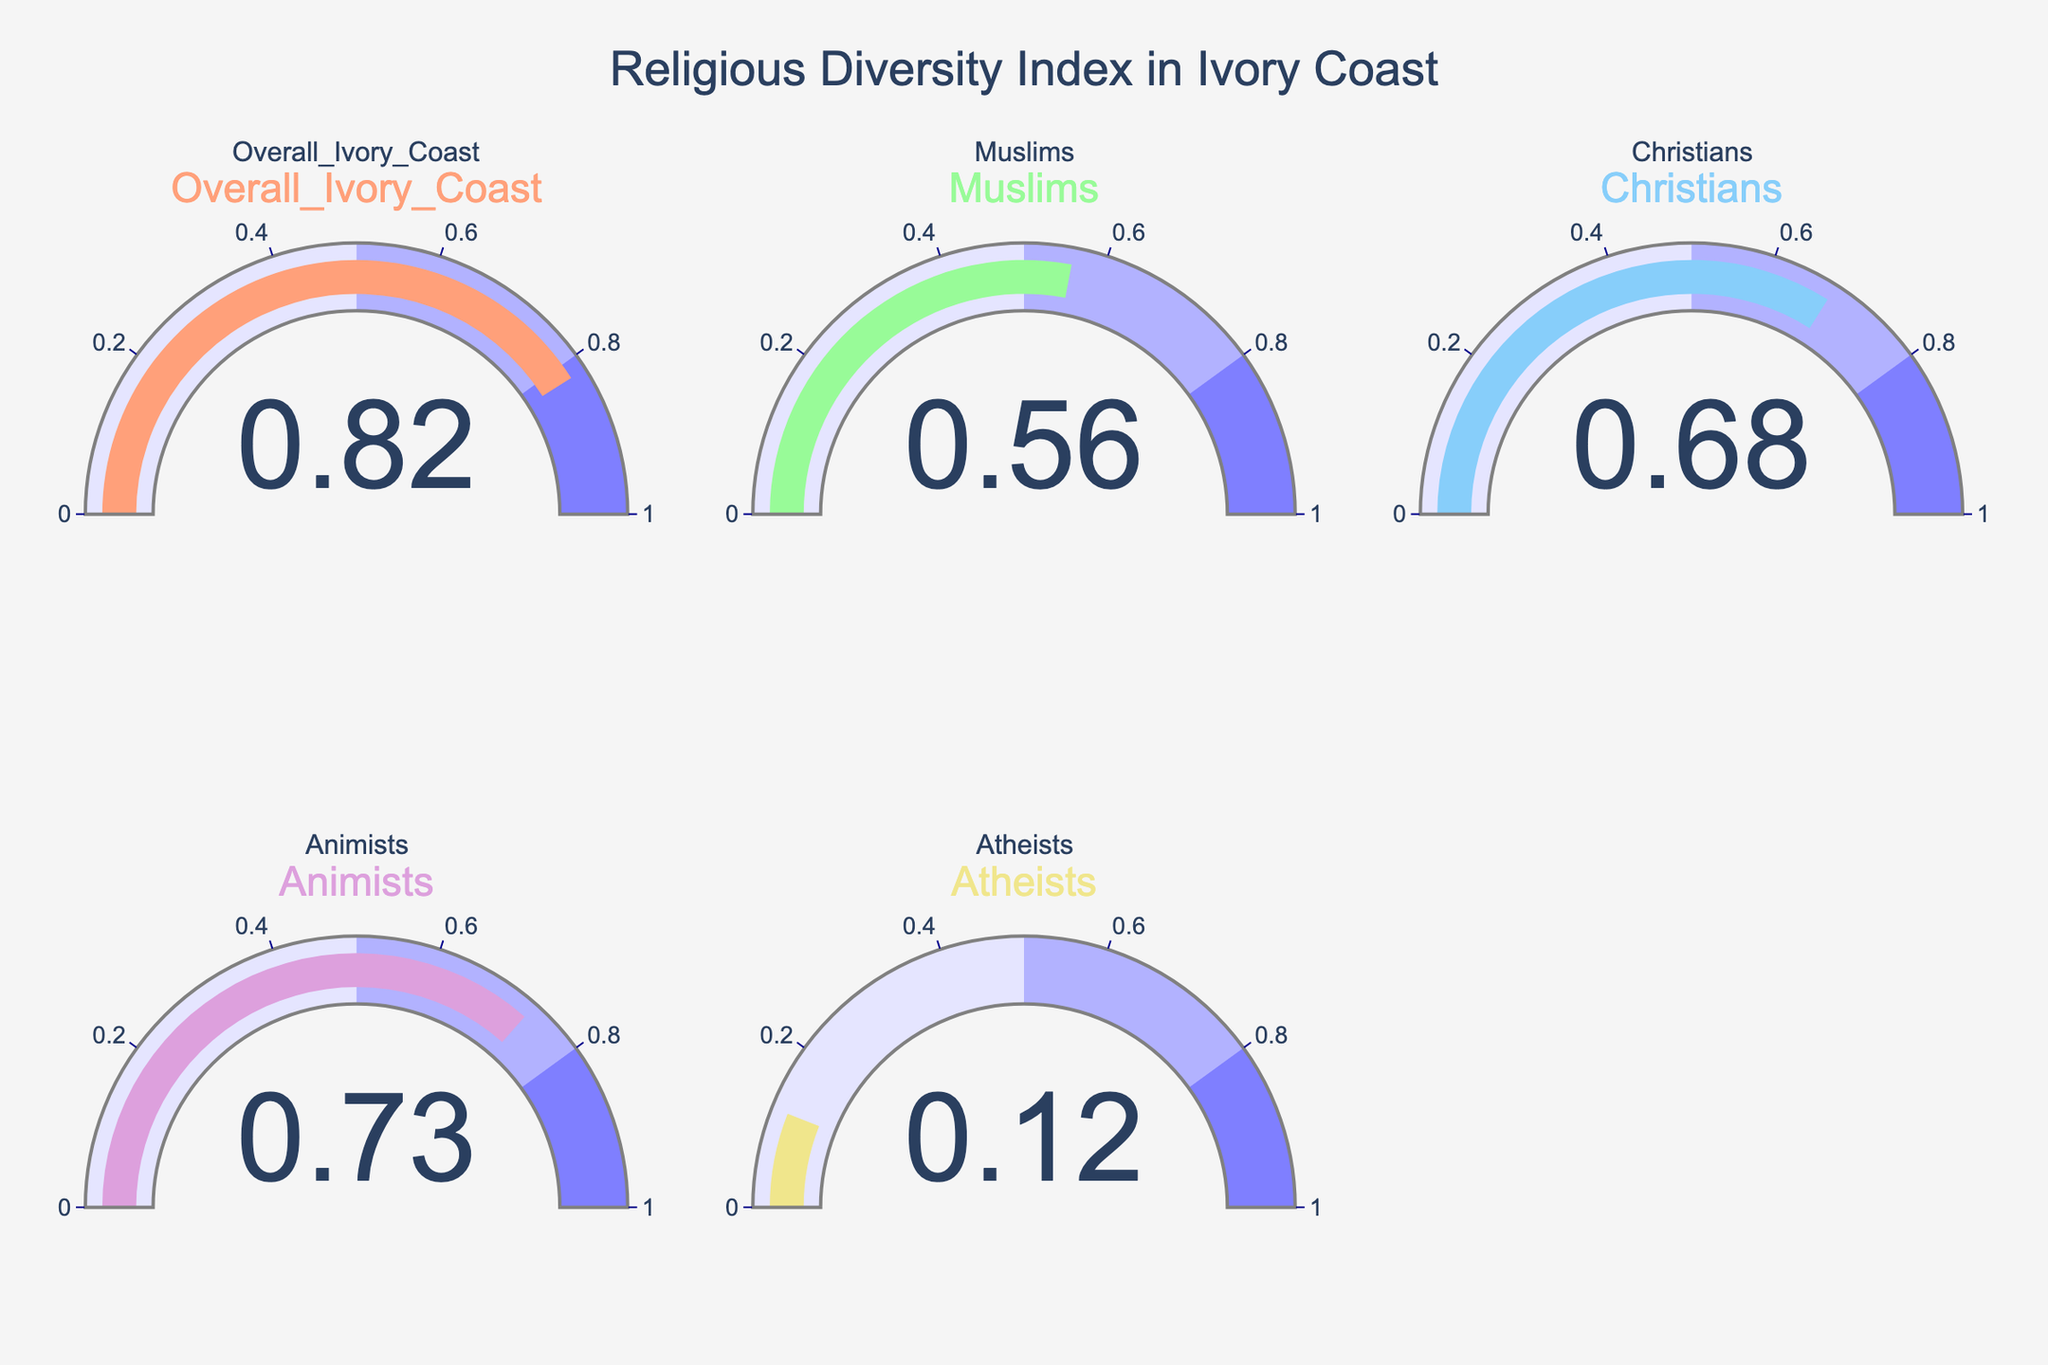What's the highest Religious Diversity Index displayed on the figure? By looking at the figure, observe which gauge has the highest value. The gauge for "Overall Ivory Coast" shows the highest Diversity Index of 0.82.
Answer: 0.82 Which group has the lowest Religious Diversity Index? By examining the values on each gauge chart, identify the smallest value. The "Atheists" group has the lowest Diversity Index of 0.12.
Answer: Atheists How much higher is the Diversity Index of Christians compared to Muslims? Find the Diversity Index of Christians (0.68) and Muslims (0.56), then calculate the difference: 0.68 - 0.56 = 0.12.
Answer: 0.12 What is the average Religious Diversity Index of all groups shown? Add the Diversity Index values of all groups: 0.82 + 0.56 + 0.68 + 0.73 + 0.12 = 2.91. Then, divide by the number of groups, which is 5: 2.91 / 5 = 0.582.
Answer: 0.582 Which groups have a Diversity Index greater than 0.70? Check each gauge chart and list groups with values over 0.70. "Overall Ivory Coast" with 0.82 and "Animists" with 0.73 have indices over 0.70.
Answer: Overall Ivory Coast, Animists What is the range of the Religious Diversity Index values displayed on the figure? The range is calculated by subtracting the smallest value (0.12 in Atheists) from the largest value (0.82 in Overall Ivory Coast): 0.82 - 0.12 = 0.70.
Answer: 0.70 What percentage of the maximum possible Diversity Index is the Animists' Diversity Index? The maximum possible index is 1. The Animists' index is 0.73. To find the percentage, use the formula (0.73 / 1) * 100 = 73%.
Answer: 73% Is the Diversity Index value for Muslims above the halfway mark of the scale? The halfway mark of the gauge scale is 0.5. The Muslims' Diversity Index is 0.56, which is above 0.5.
Answer: Yes 